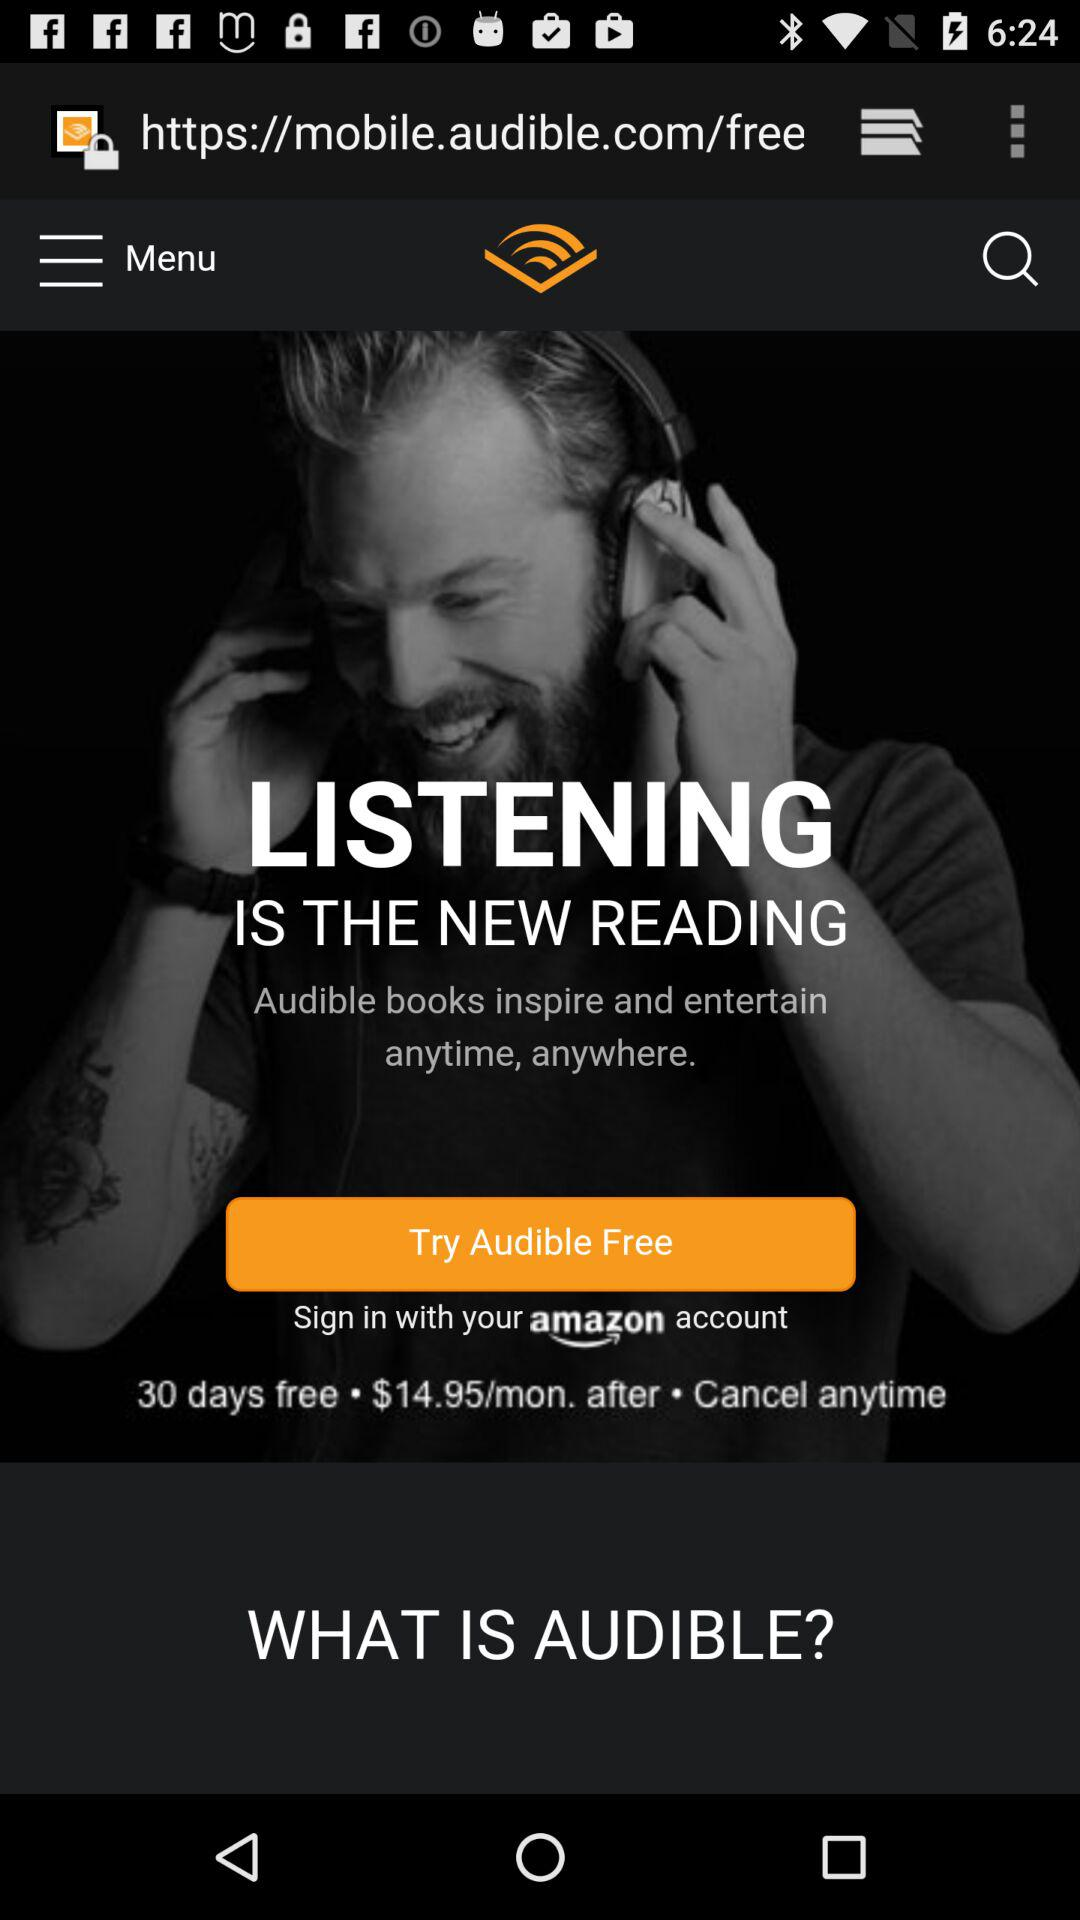What is the membership price for the application per month? The membership price is $14.95 per month. 